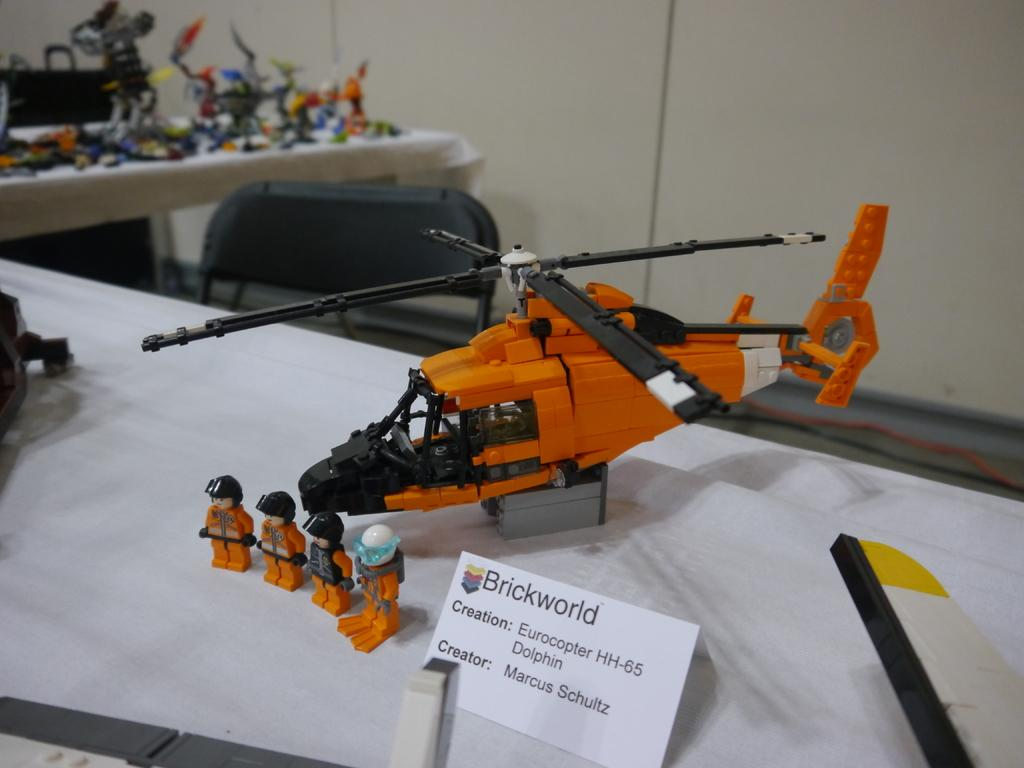Provide a one-sentence caption for the provided image. The helicopter model is a Eurocopter HH-65 Dolphin, which was created by Marcus Schultz of Brickworld. 